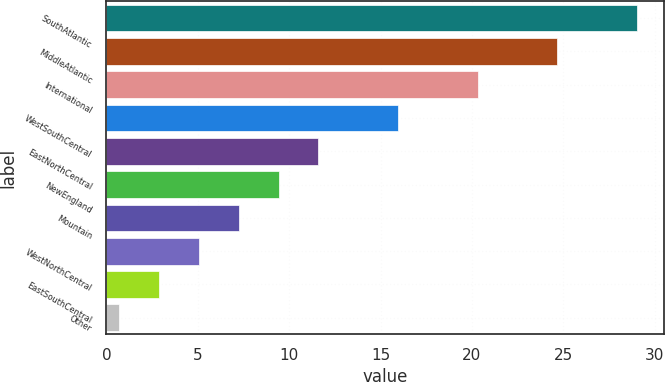Convert chart. <chart><loc_0><loc_0><loc_500><loc_500><bar_chart><fcel>SouthAtlantic<fcel>MiddleAtlantic<fcel>International<fcel>WestSouthCentral<fcel>EastNorthCentral<fcel>NewEngland<fcel>Mountain<fcel>WestNorthCentral<fcel>EastSouthCentral<fcel>Other<nl><fcel>29.04<fcel>24.68<fcel>20.32<fcel>15.96<fcel>11.6<fcel>9.42<fcel>7.24<fcel>5.06<fcel>2.88<fcel>0.7<nl></chart> 